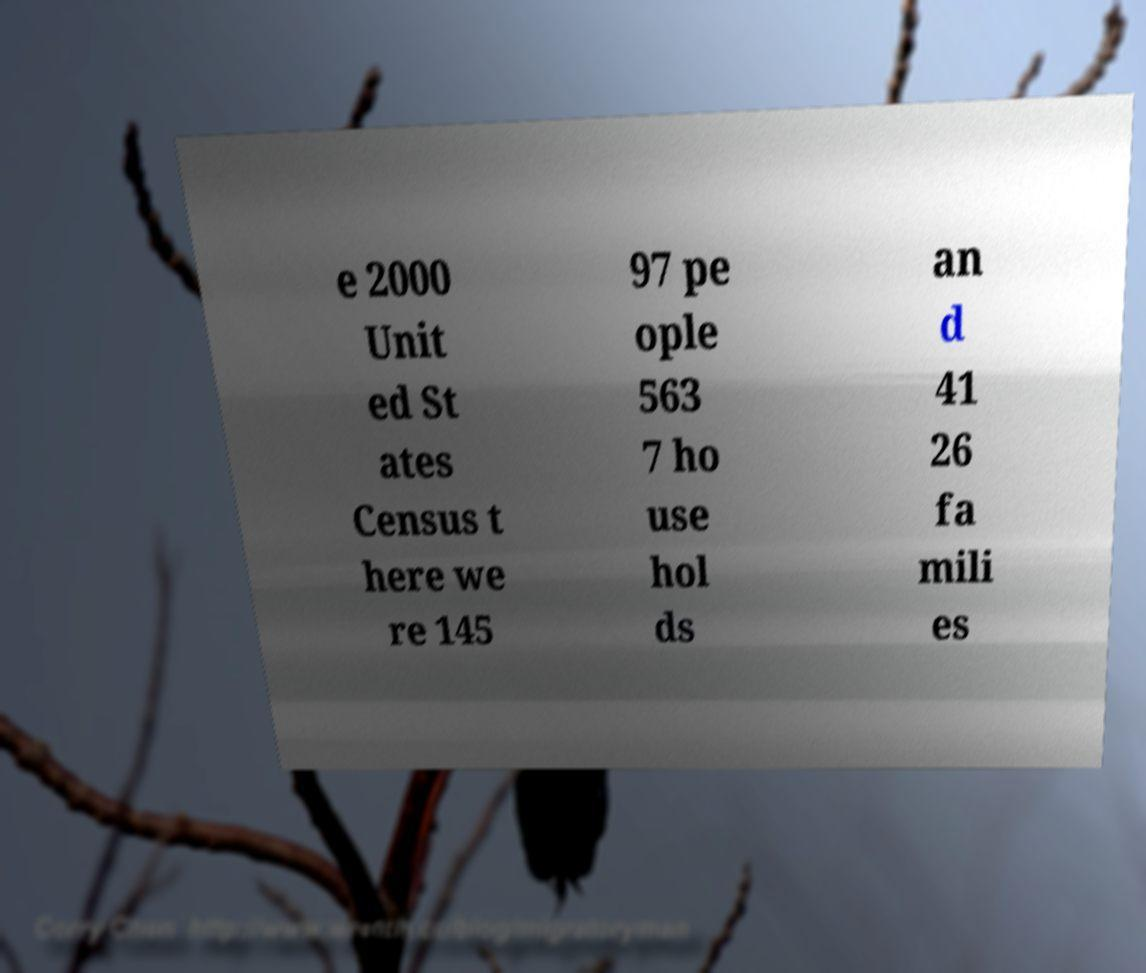Can you accurately transcribe the text from the provided image for me? e 2000 Unit ed St ates Census t here we re 145 97 pe ople 563 7 ho use hol ds an d 41 26 fa mili es 